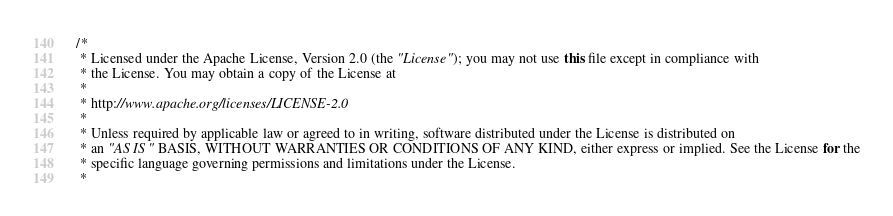<code> <loc_0><loc_0><loc_500><loc_500><_Java_>/*
 * Licensed under the Apache License, Version 2.0 (the "License"); you may not use this file except in compliance with
 * the License. You may obtain a copy of the License at
 *
 * http://www.apache.org/licenses/LICENSE-2.0
 *
 * Unless required by applicable law or agreed to in writing, software distributed under the License is distributed on
 * an "AS IS" BASIS, WITHOUT WARRANTIES OR CONDITIONS OF ANY KIND, either express or implied. See the License for the
 * specific language governing permissions and limitations under the License.
 *</code> 